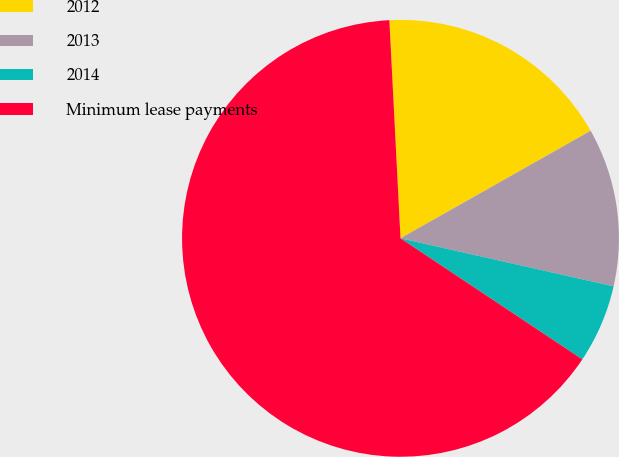Convert chart. <chart><loc_0><loc_0><loc_500><loc_500><pie_chart><fcel>2012<fcel>2013<fcel>2014<fcel>Minimum lease payments<nl><fcel>17.62%<fcel>11.72%<fcel>5.82%<fcel>64.83%<nl></chart> 